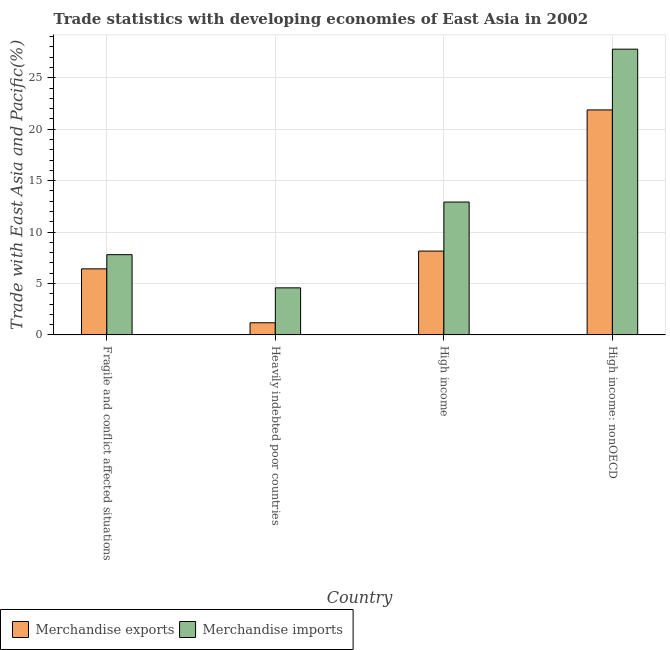How many different coloured bars are there?
Give a very brief answer. 2. How many bars are there on the 4th tick from the left?
Ensure brevity in your answer.  2. How many bars are there on the 2nd tick from the right?
Offer a terse response. 2. What is the label of the 1st group of bars from the left?
Make the answer very short. Fragile and conflict affected situations. In how many cases, is the number of bars for a given country not equal to the number of legend labels?
Your answer should be very brief. 0. What is the merchandise imports in High income?
Provide a short and direct response. 12.92. Across all countries, what is the maximum merchandise exports?
Provide a succinct answer. 21.88. Across all countries, what is the minimum merchandise exports?
Offer a very short reply. 1.18. In which country was the merchandise imports maximum?
Offer a very short reply. High income: nonOECD. In which country was the merchandise imports minimum?
Make the answer very short. Heavily indebted poor countries. What is the total merchandise exports in the graph?
Ensure brevity in your answer.  37.64. What is the difference between the merchandise exports in Fragile and conflict affected situations and that in Heavily indebted poor countries?
Give a very brief answer. 5.24. What is the difference between the merchandise exports in Heavily indebted poor countries and the merchandise imports in High income?
Your response must be concise. -11.74. What is the average merchandise imports per country?
Keep it short and to the point. 13.27. What is the difference between the merchandise exports and merchandise imports in High income: nonOECD?
Your answer should be compact. -5.91. What is the ratio of the merchandise exports in Fragile and conflict affected situations to that in Heavily indebted poor countries?
Ensure brevity in your answer.  5.44. Is the merchandise imports in Fragile and conflict affected situations less than that in High income?
Offer a terse response. Yes. Is the difference between the merchandise imports in Fragile and conflict affected situations and Heavily indebted poor countries greater than the difference between the merchandise exports in Fragile and conflict affected situations and Heavily indebted poor countries?
Your answer should be very brief. No. What is the difference between the highest and the second highest merchandise exports?
Ensure brevity in your answer.  13.73. What is the difference between the highest and the lowest merchandise exports?
Your response must be concise. 20.7. In how many countries, is the merchandise exports greater than the average merchandise exports taken over all countries?
Offer a very short reply. 1. Is the sum of the merchandise exports in Heavily indebted poor countries and High income greater than the maximum merchandise imports across all countries?
Keep it short and to the point. No. What does the 1st bar from the left in Fragile and conflict affected situations represents?
Ensure brevity in your answer.  Merchandise exports. What does the 1st bar from the right in Fragile and conflict affected situations represents?
Offer a very short reply. Merchandise imports. Are all the bars in the graph horizontal?
Provide a short and direct response. No. How many countries are there in the graph?
Offer a terse response. 4. Does the graph contain any zero values?
Keep it short and to the point. No. Does the graph contain grids?
Keep it short and to the point. Yes. Where does the legend appear in the graph?
Ensure brevity in your answer.  Bottom left. How many legend labels are there?
Give a very brief answer. 2. What is the title of the graph?
Your answer should be very brief. Trade statistics with developing economies of East Asia in 2002. What is the label or title of the X-axis?
Ensure brevity in your answer.  Country. What is the label or title of the Y-axis?
Offer a very short reply. Trade with East Asia and Pacific(%). What is the Trade with East Asia and Pacific(%) of Merchandise exports in Fragile and conflict affected situations?
Ensure brevity in your answer.  6.42. What is the Trade with East Asia and Pacific(%) in Merchandise imports in Fragile and conflict affected situations?
Make the answer very short. 7.8. What is the Trade with East Asia and Pacific(%) in Merchandise exports in Heavily indebted poor countries?
Provide a short and direct response. 1.18. What is the Trade with East Asia and Pacific(%) in Merchandise imports in Heavily indebted poor countries?
Provide a succinct answer. 4.58. What is the Trade with East Asia and Pacific(%) of Merchandise exports in High income?
Offer a very short reply. 8.15. What is the Trade with East Asia and Pacific(%) in Merchandise imports in High income?
Your response must be concise. 12.92. What is the Trade with East Asia and Pacific(%) of Merchandise exports in High income: nonOECD?
Give a very brief answer. 21.88. What is the Trade with East Asia and Pacific(%) of Merchandise imports in High income: nonOECD?
Provide a succinct answer. 27.79. Across all countries, what is the maximum Trade with East Asia and Pacific(%) in Merchandise exports?
Make the answer very short. 21.88. Across all countries, what is the maximum Trade with East Asia and Pacific(%) in Merchandise imports?
Your answer should be compact. 27.79. Across all countries, what is the minimum Trade with East Asia and Pacific(%) in Merchandise exports?
Give a very brief answer. 1.18. Across all countries, what is the minimum Trade with East Asia and Pacific(%) in Merchandise imports?
Give a very brief answer. 4.58. What is the total Trade with East Asia and Pacific(%) in Merchandise exports in the graph?
Keep it short and to the point. 37.64. What is the total Trade with East Asia and Pacific(%) of Merchandise imports in the graph?
Offer a terse response. 53.09. What is the difference between the Trade with East Asia and Pacific(%) in Merchandise exports in Fragile and conflict affected situations and that in Heavily indebted poor countries?
Offer a very short reply. 5.24. What is the difference between the Trade with East Asia and Pacific(%) in Merchandise imports in Fragile and conflict affected situations and that in Heavily indebted poor countries?
Offer a very short reply. 3.23. What is the difference between the Trade with East Asia and Pacific(%) of Merchandise exports in Fragile and conflict affected situations and that in High income?
Ensure brevity in your answer.  -1.73. What is the difference between the Trade with East Asia and Pacific(%) in Merchandise imports in Fragile and conflict affected situations and that in High income?
Offer a terse response. -5.12. What is the difference between the Trade with East Asia and Pacific(%) in Merchandise exports in Fragile and conflict affected situations and that in High income: nonOECD?
Make the answer very short. -15.45. What is the difference between the Trade with East Asia and Pacific(%) of Merchandise imports in Fragile and conflict affected situations and that in High income: nonOECD?
Provide a short and direct response. -19.98. What is the difference between the Trade with East Asia and Pacific(%) in Merchandise exports in Heavily indebted poor countries and that in High income?
Make the answer very short. -6.97. What is the difference between the Trade with East Asia and Pacific(%) of Merchandise imports in Heavily indebted poor countries and that in High income?
Ensure brevity in your answer.  -8.34. What is the difference between the Trade with East Asia and Pacific(%) of Merchandise exports in Heavily indebted poor countries and that in High income: nonOECD?
Keep it short and to the point. -20.7. What is the difference between the Trade with East Asia and Pacific(%) of Merchandise imports in Heavily indebted poor countries and that in High income: nonOECD?
Make the answer very short. -23.21. What is the difference between the Trade with East Asia and Pacific(%) of Merchandise exports in High income and that in High income: nonOECD?
Your answer should be compact. -13.73. What is the difference between the Trade with East Asia and Pacific(%) of Merchandise imports in High income and that in High income: nonOECD?
Your answer should be very brief. -14.87. What is the difference between the Trade with East Asia and Pacific(%) in Merchandise exports in Fragile and conflict affected situations and the Trade with East Asia and Pacific(%) in Merchandise imports in Heavily indebted poor countries?
Ensure brevity in your answer.  1.85. What is the difference between the Trade with East Asia and Pacific(%) in Merchandise exports in Fragile and conflict affected situations and the Trade with East Asia and Pacific(%) in Merchandise imports in High income?
Offer a terse response. -6.49. What is the difference between the Trade with East Asia and Pacific(%) in Merchandise exports in Fragile and conflict affected situations and the Trade with East Asia and Pacific(%) in Merchandise imports in High income: nonOECD?
Your answer should be compact. -21.36. What is the difference between the Trade with East Asia and Pacific(%) in Merchandise exports in Heavily indebted poor countries and the Trade with East Asia and Pacific(%) in Merchandise imports in High income?
Keep it short and to the point. -11.74. What is the difference between the Trade with East Asia and Pacific(%) of Merchandise exports in Heavily indebted poor countries and the Trade with East Asia and Pacific(%) of Merchandise imports in High income: nonOECD?
Ensure brevity in your answer.  -26.61. What is the difference between the Trade with East Asia and Pacific(%) in Merchandise exports in High income and the Trade with East Asia and Pacific(%) in Merchandise imports in High income: nonOECD?
Your answer should be compact. -19.63. What is the average Trade with East Asia and Pacific(%) of Merchandise exports per country?
Your answer should be very brief. 9.41. What is the average Trade with East Asia and Pacific(%) in Merchandise imports per country?
Ensure brevity in your answer.  13.27. What is the difference between the Trade with East Asia and Pacific(%) in Merchandise exports and Trade with East Asia and Pacific(%) in Merchandise imports in Fragile and conflict affected situations?
Offer a terse response. -1.38. What is the difference between the Trade with East Asia and Pacific(%) in Merchandise exports and Trade with East Asia and Pacific(%) in Merchandise imports in Heavily indebted poor countries?
Give a very brief answer. -3.4. What is the difference between the Trade with East Asia and Pacific(%) in Merchandise exports and Trade with East Asia and Pacific(%) in Merchandise imports in High income?
Your response must be concise. -4.77. What is the difference between the Trade with East Asia and Pacific(%) in Merchandise exports and Trade with East Asia and Pacific(%) in Merchandise imports in High income: nonOECD?
Ensure brevity in your answer.  -5.91. What is the ratio of the Trade with East Asia and Pacific(%) in Merchandise exports in Fragile and conflict affected situations to that in Heavily indebted poor countries?
Ensure brevity in your answer.  5.44. What is the ratio of the Trade with East Asia and Pacific(%) in Merchandise imports in Fragile and conflict affected situations to that in Heavily indebted poor countries?
Provide a short and direct response. 1.71. What is the ratio of the Trade with East Asia and Pacific(%) in Merchandise exports in Fragile and conflict affected situations to that in High income?
Provide a short and direct response. 0.79. What is the ratio of the Trade with East Asia and Pacific(%) of Merchandise imports in Fragile and conflict affected situations to that in High income?
Provide a succinct answer. 0.6. What is the ratio of the Trade with East Asia and Pacific(%) of Merchandise exports in Fragile and conflict affected situations to that in High income: nonOECD?
Provide a succinct answer. 0.29. What is the ratio of the Trade with East Asia and Pacific(%) of Merchandise imports in Fragile and conflict affected situations to that in High income: nonOECD?
Ensure brevity in your answer.  0.28. What is the ratio of the Trade with East Asia and Pacific(%) in Merchandise exports in Heavily indebted poor countries to that in High income?
Provide a short and direct response. 0.14. What is the ratio of the Trade with East Asia and Pacific(%) of Merchandise imports in Heavily indebted poor countries to that in High income?
Give a very brief answer. 0.35. What is the ratio of the Trade with East Asia and Pacific(%) of Merchandise exports in Heavily indebted poor countries to that in High income: nonOECD?
Make the answer very short. 0.05. What is the ratio of the Trade with East Asia and Pacific(%) in Merchandise imports in Heavily indebted poor countries to that in High income: nonOECD?
Give a very brief answer. 0.16. What is the ratio of the Trade with East Asia and Pacific(%) in Merchandise exports in High income to that in High income: nonOECD?
Give a very brief answer. 0.37. What is the ratio of the Trade with East Asia and Pacific(%) in Merchandise imports in High income to that in High income: nonOECD?
Your answer should be very brief. 0.46. What is the difference between the highest and the second highest Trade with East Asia and Pacific(%) in Merchandise exports?
Offer a very short reply. 13.73. What is the difference between the highest and the second highest Trade with East Asia and Pacific(%) in Merchandise imports?
Provide a short and direct response. 14.87. What is the difference between the highest and the lowest Trade with East Asia and Pacific(%) of Merchandise exports?
Offer a terse response. 20.7. What is the difference between the highest and the lowest Trade with East Asia and Pacific(%) in Merchandise imports?
Make the answer very short. 23.21. 